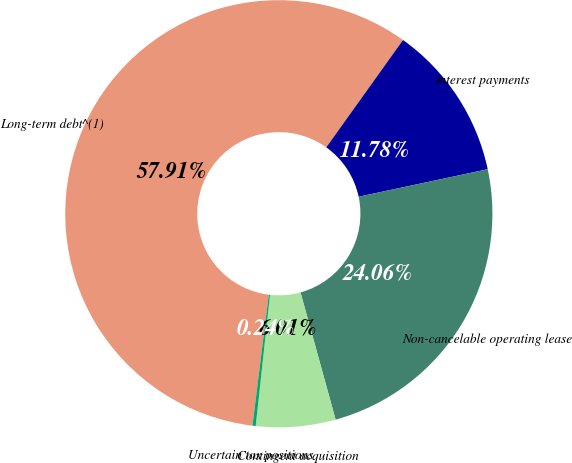<chart> <loc_0><loc_0><loc_500><loc_500><pie_chart><fcel>Long-term debt^(1)<fcel>Interest payments<fcel>Non-cancelable operating lease<fcel>Contingent acquisition<fcel>Uncertain tax positions<nl><fcel>57.91%<fcel>11.78%<fcel>24.06%<fcel>6.01%<fcel>0.24%<nl></chart> 